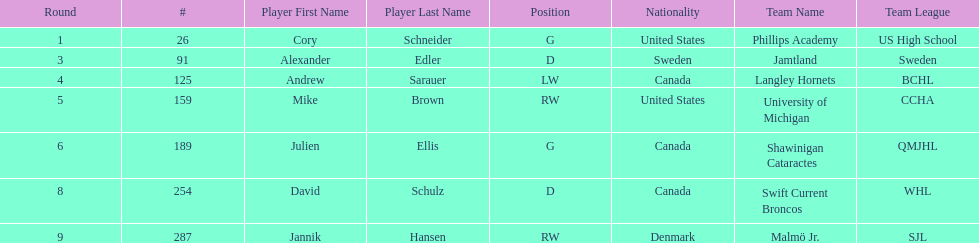Give me the full table as a dictionary. {'header': ['Round', '#', 'Player First Name', 'Player Last Name', 'Position', 'Nationality', 'Team Name', 'Team League'], 'rows': [['1', '26', 'Cory', 'Schneider', 'G', 'United States', 'Phillips Academy', 'US High School'], ['3', '91', 'Alexander', 'Edler', 'D', 'Sweden', 'Jamtland', 'Sweden'], ['4', '125', 'Andrew', 'Sarauer', 'LW', 'Canada', 'Langley Hornets', 'BCHL'], ['5', '159', 'Mike', 'Brown', 'RW', 'United States', 'University of Michigan', 'CCHA'], ['6', '189', 'Julien', 'Ellis', 'G', 'Canada', 'Shawinigan Cataractes', 'QMJHL'], ['8', '254', 'David', 'Schulz', 'D', 'Canada', 'Swift Current Broncos', 'WHL'], ['9', '287', 'Jannik', 'Hansen', 'RW', 'Denmark', 'Malmö Jr.', 'SJL']]} How many players are from the united states? 2. 